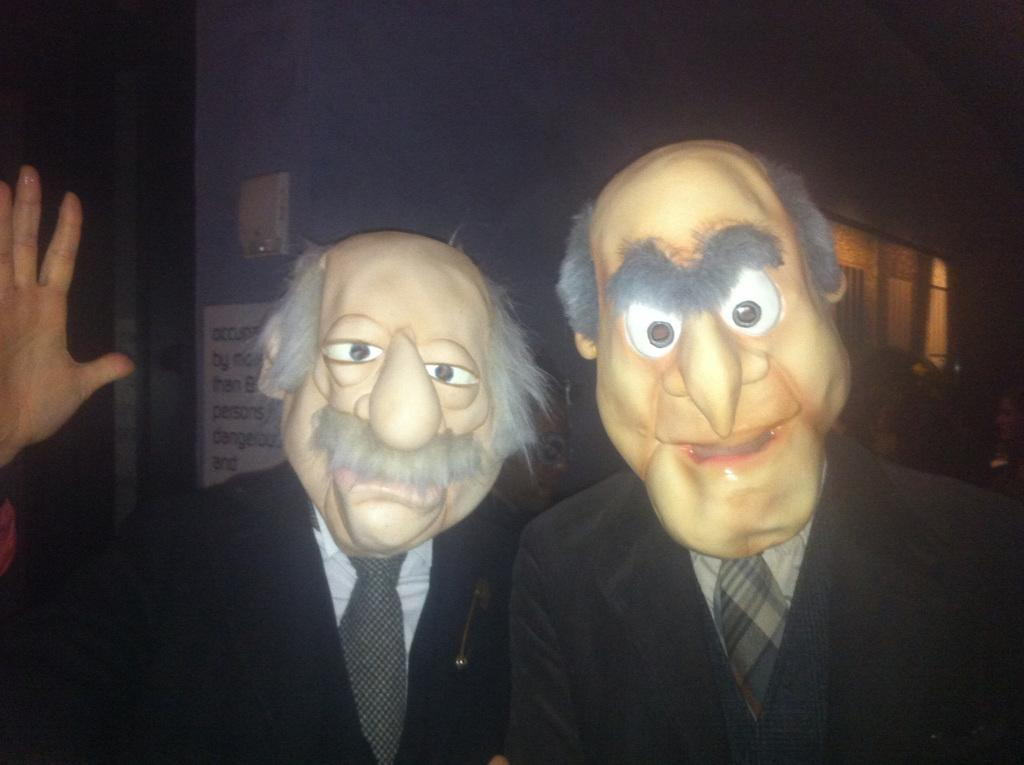How many people are in the image? There are two persons in the image. What are the persons wearing on their faces? Both persons are wearing masks. What can be seen in the background of the image? There is a wall in the background of the image. Is there any text or symbol on the wall? Yes, there is a label on the wall. How strong is the grip of the water on the wall in the image? There is no water present in the image, so it is not possible to determine the strength of its grip on the wall. 